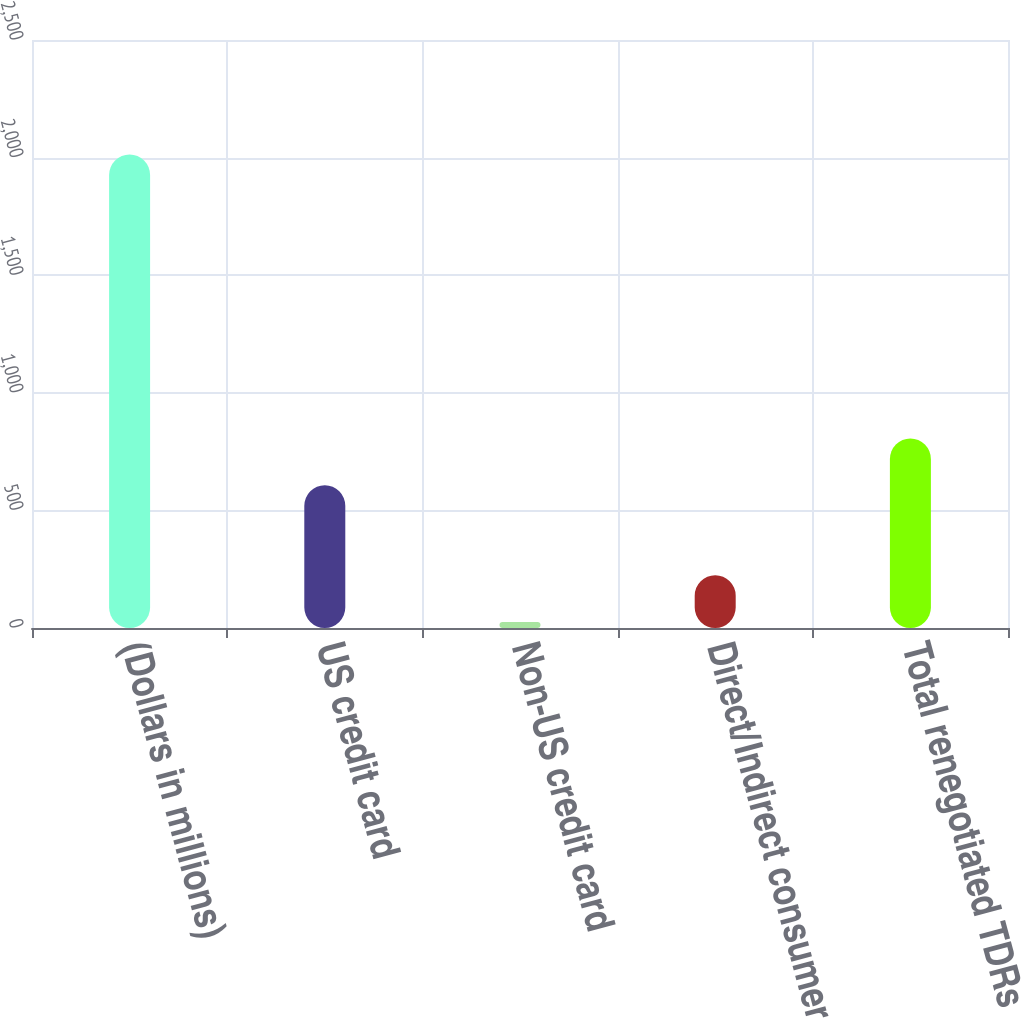<chart> <loc_0><loc_0><loc_500><loc_500><bar_chart><fcel>(Dollars in millions)<fcel>US credit card<fcel>Non-US credit card<fcel>Direct/Indirect consumer<fcel>Total renegotiated TDRs<nl><fcel>2013<fcel>607<fcel>26<fcel>224.7<fcel>805.7<nl></chart> 